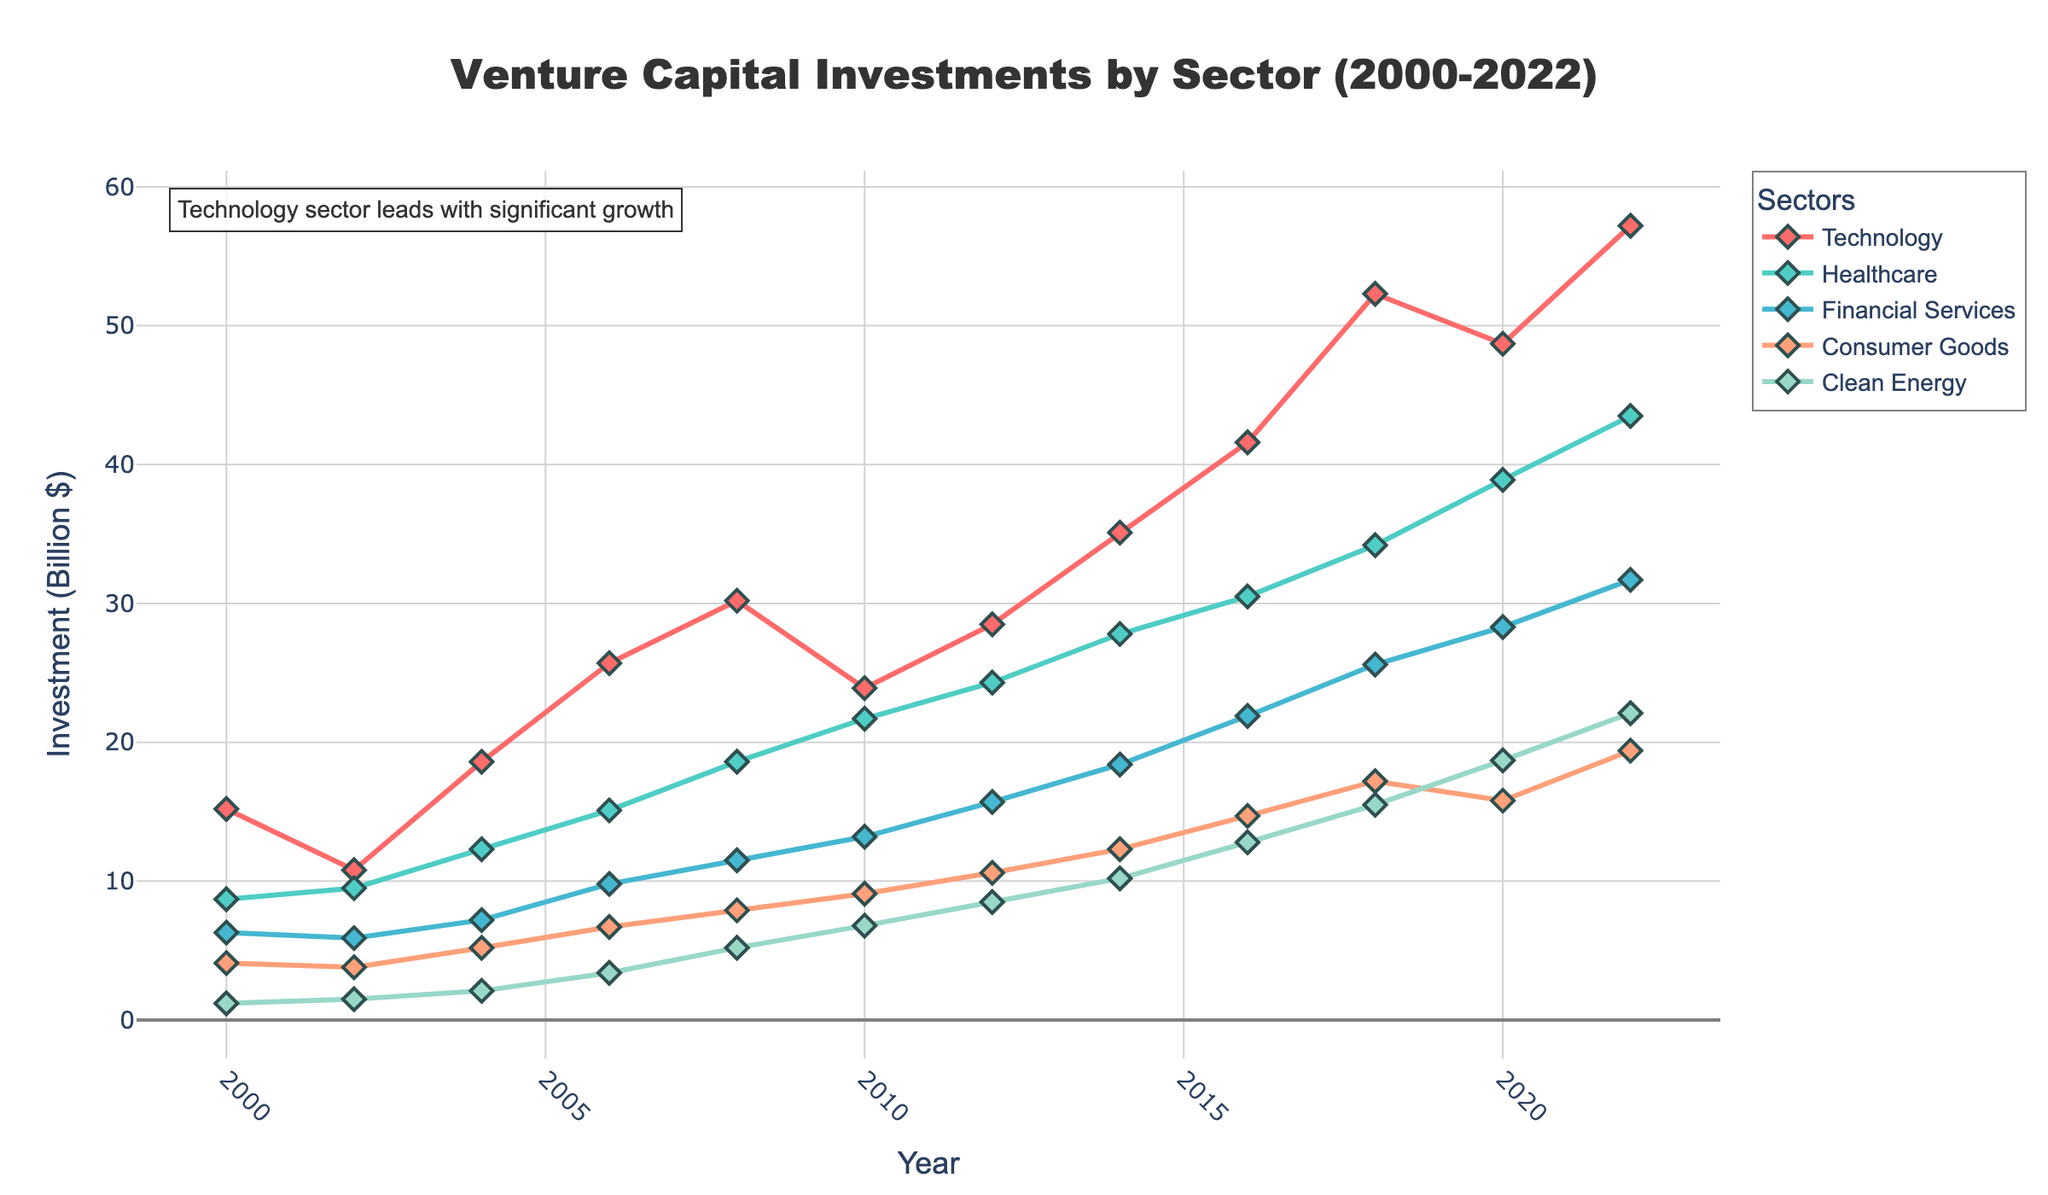What's the trend in venture capital investments in the Technology sector from 2000 to 2022? From the chart, we can observe the trend line of investments in the Technology sector. The investment starts at $15.2 billion in 2000, increases over the years to $57.2 billion in 2022. The trend exhibits consistent growth, especially after 2012.
Answer: Increase Which sector saw the highest investment in 2022? By comparing the ending points of the lines for all sectors in 2022, it's clear that the Technology sector, with an investment of $57.2 billion, had the highest investment.
Answer: Technology How did investments in the Healthcare sector change between 2010 and 2012? The investment in the Healthcare sector increased from $21.7 billion in 2010 to $24.3 billion in 2012. The change can be calculated as $24.3 billion minus $21.7 billion.
Answer: Increased by $2.6 billion Which sector shows the least investment growth over the entire period? Observing the slope and the growth trajectory of all the lines, Clean Energy starts at $1.2 billion in 2000 and ends at $22.1 billion in 2022, which is the smallest growth compared to other sectors.
Answer: Clean Energy What is the difference in venture capital investments between Financial Services and Consumer Goods in 2020? The ending points of both sectors in 2020 show investments of $28.3 billion for Financial Services and $15.8 billion for Consumer Goods. The difference is $28.3 billion minus $15.8 billion.
Answer: $12.5 billion Among the sectors, which one showed the most improvement in investment from 2000 to 2002? By comparing the vertical distances between points for all sectors from 2000 to 2002, Healthcare shows an increase from $8.7 billion to $9.5 billion, which seems to be the most significant among the sectors.
Answer: Healthcare How did the investment in Clean Energy change from 2008 to 2012? Clean Energy investments grew from $5.2 billion in 2008 to $8.5 billion in 2012. The increment is $8.5 billion minus $5.2 billion.
Answer: Increased by $3.3 billion What was the overall trend for Consumer Goods sector's investment from 2000 to 2022? Tracking the Consumer Goods line from 2000 ($4.1 billion) to 2022 ($19.4 billion), we can see a steady and consistent increase throughout the period.
Answer: Steady Increase During which year did the Technology sector surpass $30 billion in investments? Following the trajectory of the Technology sector's line, it surpasses $30 billion between 2008 ($30.2 billion) and 2010 ($23.9 billion). Thus, the year is 2008.
Answer: 2008 Compare the investments in the Technology and Clean Energy sectors in 2016. In 2016, the investments were $41.6 billion for Technology and $12.8 billion for Clean Energy.
Answer: Technology had $28.8 billion more than Clean Energy 